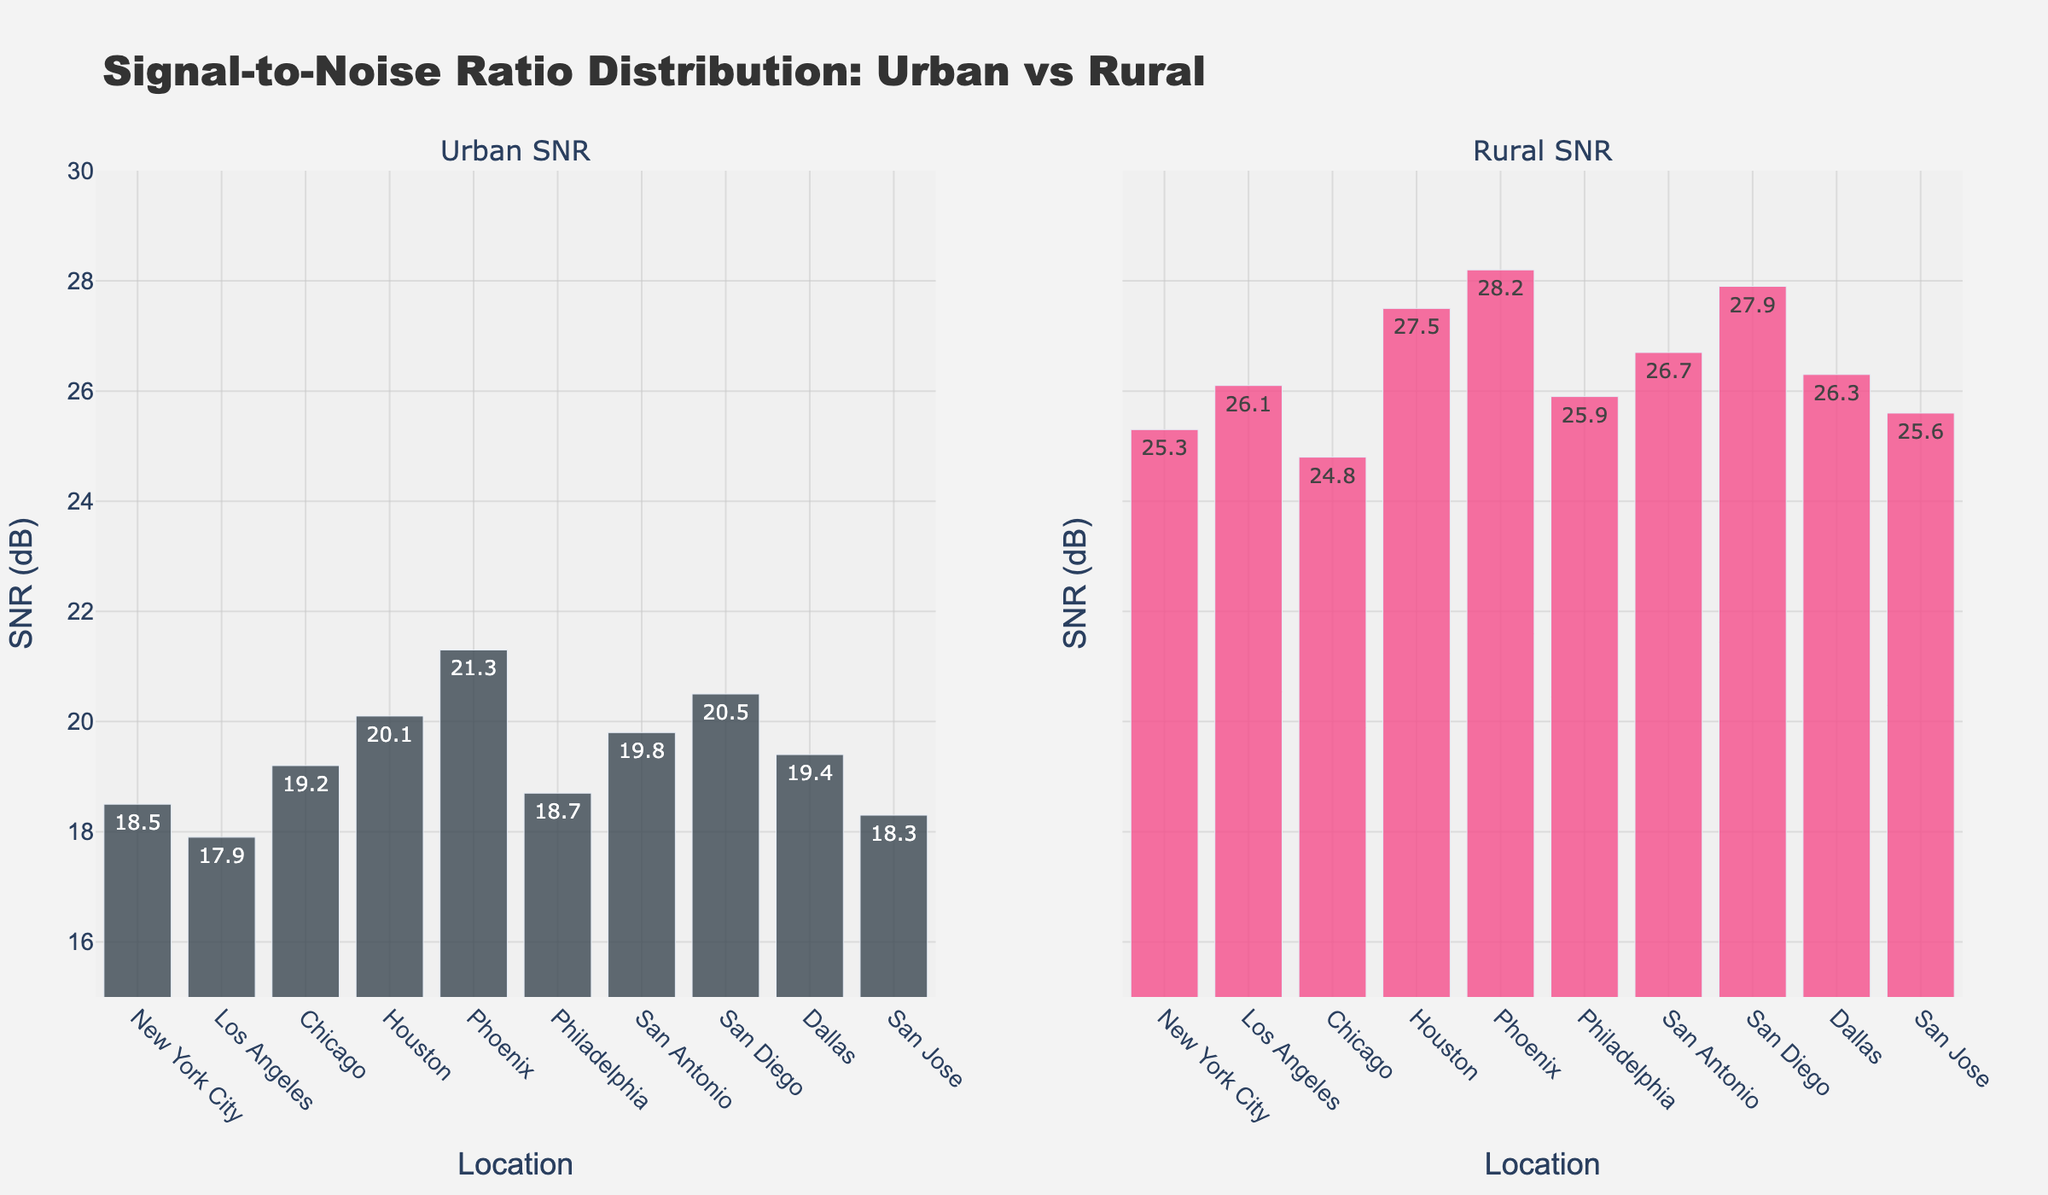Which subplot shows the higher Median SNR values, Urban or Rural? Calculate the median value for each subplot. Urban SNR values: 18.5, 17.9, 19.2, 20.1, 21.3, 18.7, 19.8, 20.5, 19.4, 18.3. Sorted: 17.9, 18.3, 18.5, 18.7, 19.2, 19.4, 19.8, 20.1, 20.5, 21.3. Median is the average of 5th and 6th values: (19.2 + 19.4) / 2 = 19.3. Rural SNR values: 25.3, 26.1, 24.8, 27.5, 28.2, 25.9, 26.7, 27.9, 26.3, 25.6. Sorted: 24.8, 25.3, 25.6, 25.9, 26.1, 26.3, 26.7, 27.5, 27.9, 28.2. Median is the average of 5th and 6th values: (26.1 + 26.3) / 2 = 26.2. Rural has a higher median value.
Answer: Rural Which city has the highest Urban SNR value, and what is that value? From the Urban subplot, Phoenix has the highest bar with a value of 21.3 dB.
Answer: Phoenix, 21.3 dB What is the range of the Rural SNR values? The range is calculated by subtracting the minimum value from the maximum value. Minimum value = 24.8 dB, Maximum value = 28.2 dB. Range = 28.2 dB - 24.8 dB = 3.4 dB.
Answer: 3.4 dB How do the Rural SNR values in San Antonio and San Diego compare? From the Rural subplot, San Antonio has an SNR value of 26.7 dB, and San Diego has an SNR value of 27.9 dB. San Diego's SNR value is higher by 27.9 - 26.7 = 1.2 dB.
Answer: San Diego's SNR is higher by 1.2 dB Is the average Urban SNR higher or lower than the average Rural SNR? Calculate the average for both: Urban SNR sum = 193.7, average = 193.7/10 = 19.37 dB. Rural SNR sum = 264.3, average = 264.3/10 = 26.43 dB. The average Urban SNR (19.37 dB) is lower than the average Rural SNR (26.43 dB).
Answer: Lower What is the overall trend in SNR values when comparing Urban and Rural areas in this figure? Most of the Rural SNR values are noticeably higher than the corresponding Urban SNR values, indicating better signal performance in rural areas.
Answer: Rural SNR values are generally higher 